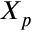<formula> <loc_0><loc_0><loc_500><loc_500>X _ { p }</formula> 